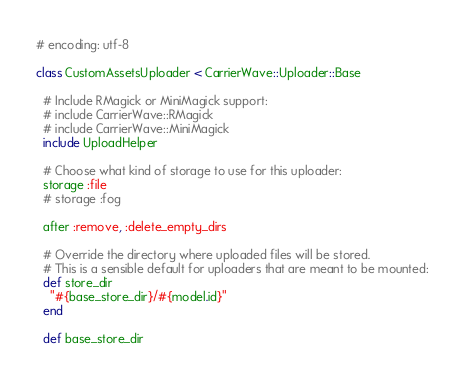Convert code to text. <code><loc_0><loc_0><loc_500><loc_500><_Ruby_># encoding: utf-8

class CustomAssetsUploader < CarrierWave::Uploader::Base

  # Include RMagick or MiniMagick support:
  # include CarrierWave::RMagick
  # include CarrierWave::MiniMagick
  include UploadHelper

  # Choose what kind of storage to use for this uploader:
  storage :file
  # storage :fog

  after :remove, :delete_empty_dirs

  # Override the directory where uploaded files will be stored.
  # This is a sensible default for uploaders that are meant to be mounted:
  def store_dir
    "#{base_store_dir}/#{model.id}"
  end

  def base_store_dir</code> 